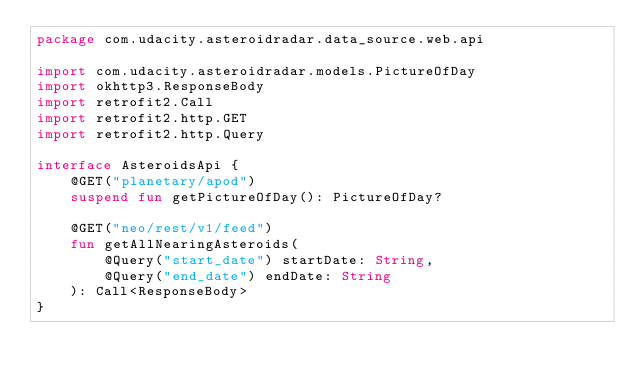<code> <loc_0><loc_0><loc_500><loc_500><_Kotlin_>package com.udacity.asteroidradar.data_source.web.api

import com.udacity.asteroidradar.models.PictureOfDay
import okhttp3.ResponseBody
import retrofit2.Call
import retrofit2.http.GET
import retrofit2.http.Query

interface AsteroidsApi {
    @GET("planetary/apod")
    suspend fun getPictureOfDay(): PictureOfDay?

    @GET("neo/rest/v1/feed")
    fun getAllNearingAsteroids(
        @Query("start_date") startDate: String,
        @Query("end_date") endDate: String
    ): Call<ResponseBody>
}</code> 